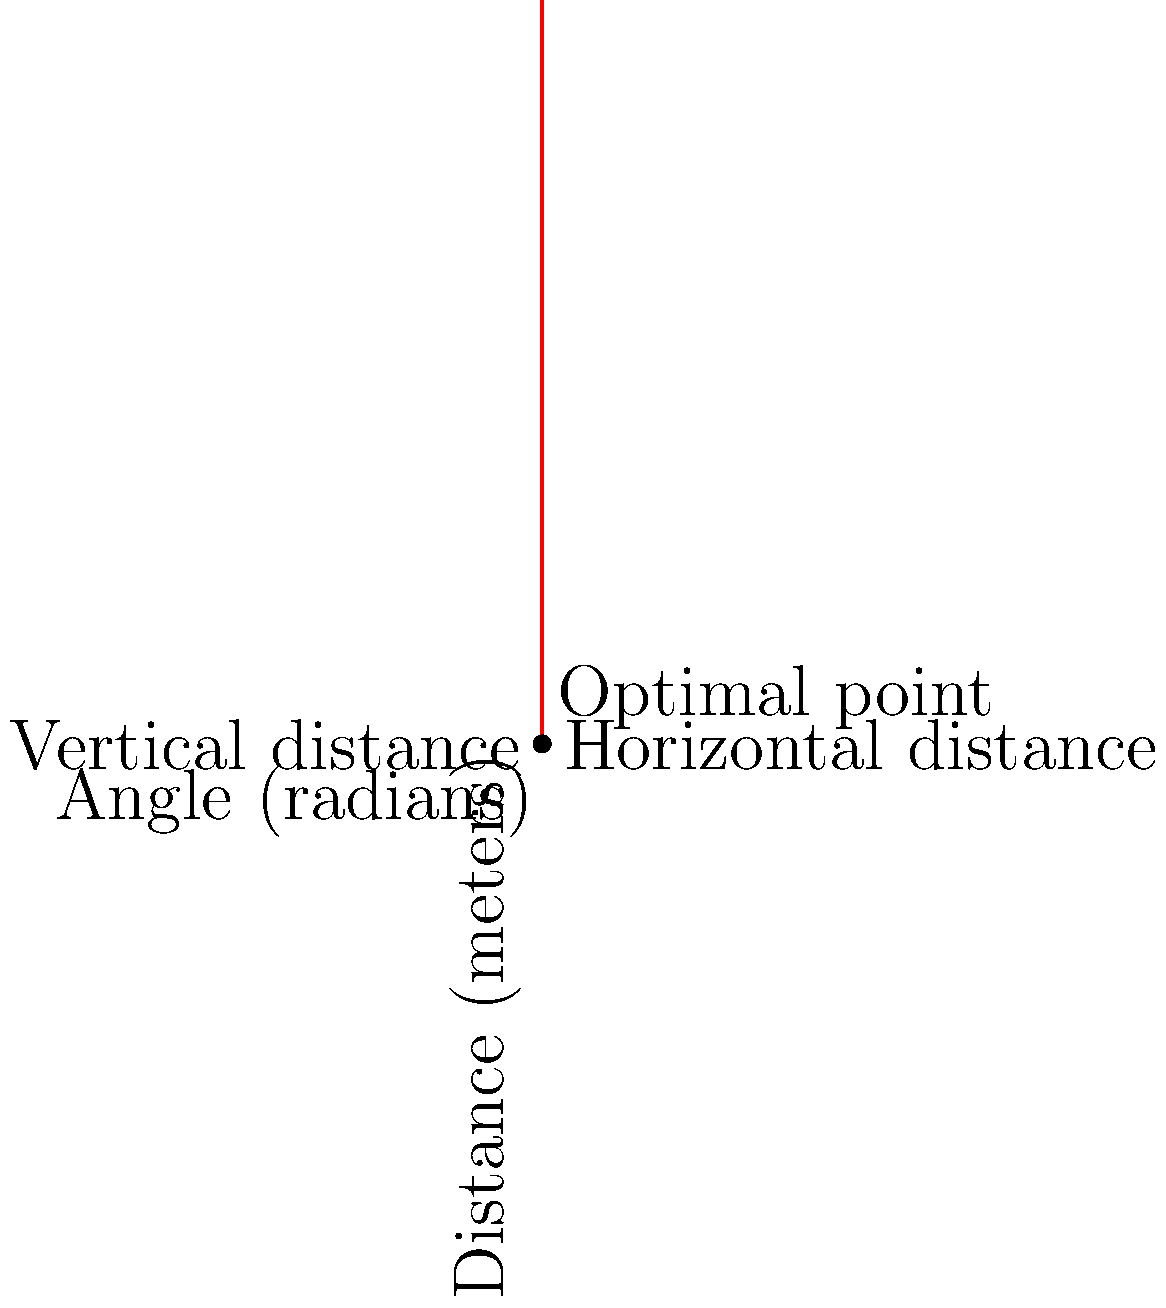As a photojournalist inspired by Sani Maikatanga's work, you're trying to capture the perfect shot of a monument. The monument is 10 meters tall and stands 5 meters away from where you can position yourself. To find the best viewing angle, you need to maximize the ratio of the vertical distance to the horizontal distance in your field of view. If $\theta$ represents the angle between the ground and your line of sight to the top of the monument, find the optimal angle $\theta$ (in radians) that maximizes this ratio. Let's approach this step-by-step:

1) First, we need to express the vertical and horizontal distances in terms of $\theta$:
   Vertical distance: $V = 10 \sin(\theta)$
   Horizontal distance: $H = 5 / \cos(\theta)$

2) The ratio we want to maximize is:
   $R = \frac{V}{H} = \frac{10 \sin(\theta)}{5 / \cos(\theta)} = 2 \sin(\theta) \cos(\theta)$

3) We can simplify this using the trigonometric identity $\sin(2\theta) = 2\sin(\theta)\cos(\theta)$:
   $R = \sin(2\theta)$

4) To find the maximum value of $R$, we need to find where its derivative equals zero:
   $\frac{dR}{d\theta} = 2\cos(2\theta)$

5) Set this equal to zero and solve:
   $2\cos(2\theta) = 0$
   $\cos(2\theta) = 0$
   $2\theta = \frac{\pi}{2}$
   $\theta = \frac{\pi}{4}$

6) To confirm this is a maximum, we can check the second derivative:
   $\frac{d^2R}{d\theta^2} = -4\sin(2\theta)$
   At $\theta = \frac{\pi}{4}$, this is negative, confirming a maximum.

Therefore, the optimal angle is $\frac{\pi}{4}$ radians, or 45 degrees.
Answer: $\frac{\pi}{4}$ radians 